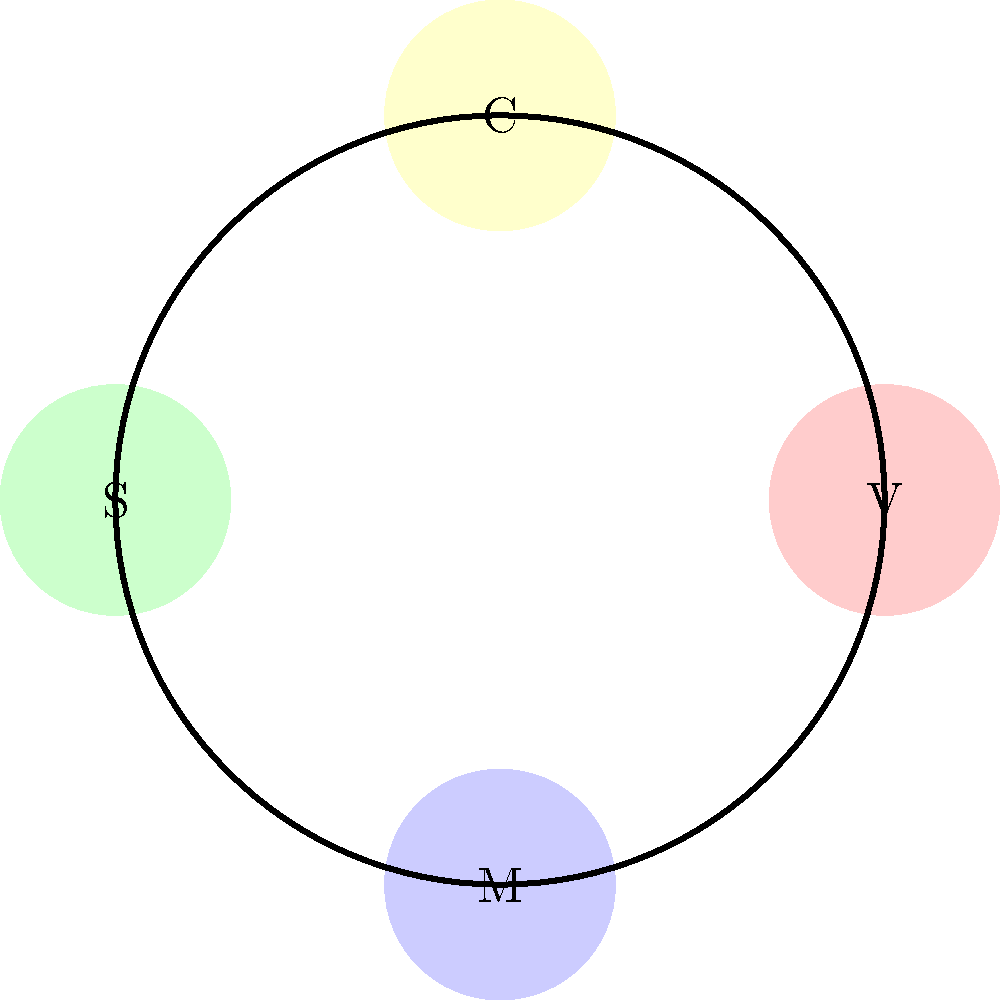Kohr's Frozen Custard introduces a new circular flavor selection wheel with four flavors: Vanilla (V), Chocolate (C), Strawberry (S), and Mint (M), arranged clockwise as shown in the diagram. If we consider rotations of this wheel as the group operation, what is the order of the subgroup generated by rotating the wheel clockwise by 90 degrees? Let's approach this step-by-step:

1) First, we need to understand what the group operation is. In this case, it's the rotation of the wheel by 90 degrees clockwise.

2) Let's call this operation $r$. So, $r$ represents a 90-degree clockwise rotation.

3) Now, let's see what happens when we apply $r$ multiple times:
   - $r$: (V, C, S, M) → (M, V, C, S)
   - $r^2$: (M, V, C, S) → (S, M, V, C)
   - $r^3$: (S, M, V, C) → (C, S, M, V)
   - $r^4$: (C, S, M, V) → (V, C, S, M)

4) We see that $r^4$ brings us back to the original position. This means that the subgroup generated by $r$ has 4 elements: $\{e, r, r^2, r^3\}$, where $e$ is the identity element (no rotation).

5) In group theory, the order of a group is the number of elements in the group.

Therefore, the order of the subgroup generated by rotating the wheel clockwise by 90 degrees is 4.
Answer: 4 